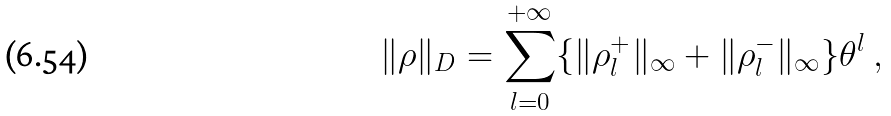<formula> <loc_0><loc_0><loc_500><loc_500>\| \rho \| _ { D } = \sum _ { l = 0 } ^ { + \infty } \{ \| \rho _ { l } ^ { + } \| _ { \infty } + \| \rho _ { l } ^ { - } \| _ { \infty } \} \theta ^ { l } \ ,</formula> 